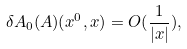<formula> <loc_0><loc_0><loc_500><loc_500>\delta A _ { 0 } ( A ) ( x ^ { 0 } , x ) = O ( \frac { 1 } { | x | } ) ,</formula> 